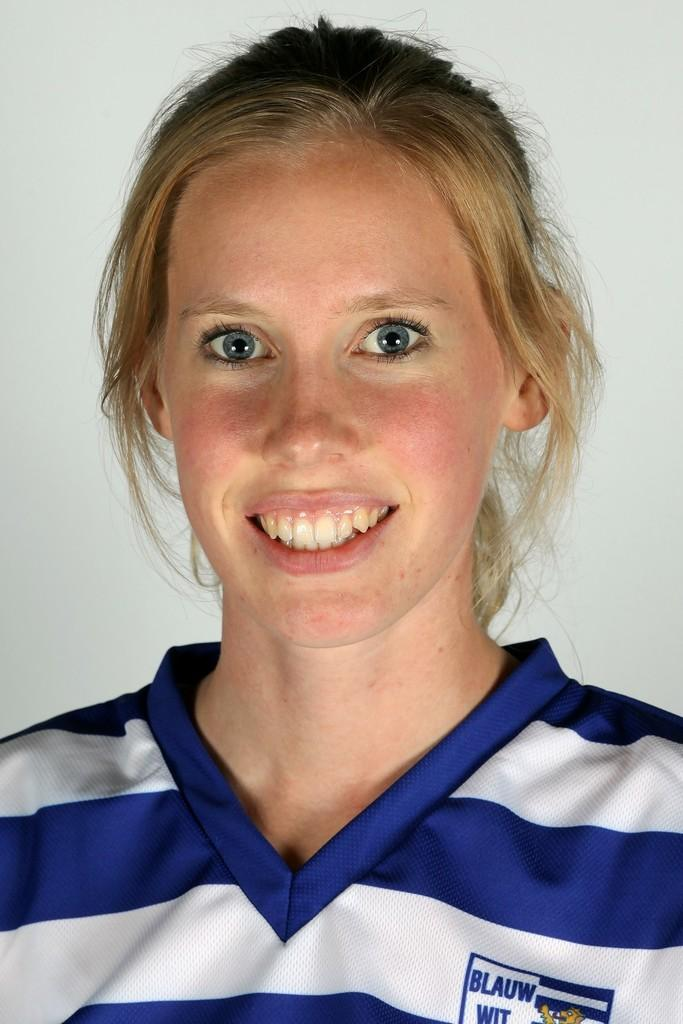What is the main subject of the image? The main subject of the image is a woman. What is the woman doing in the image? The woman is standing in the image. What is the woman's facial expression in the image? The woman is smiling in the image. How many geese are sitting on the chair next to the woman in the image? There are no geese or chairs present in the image. 